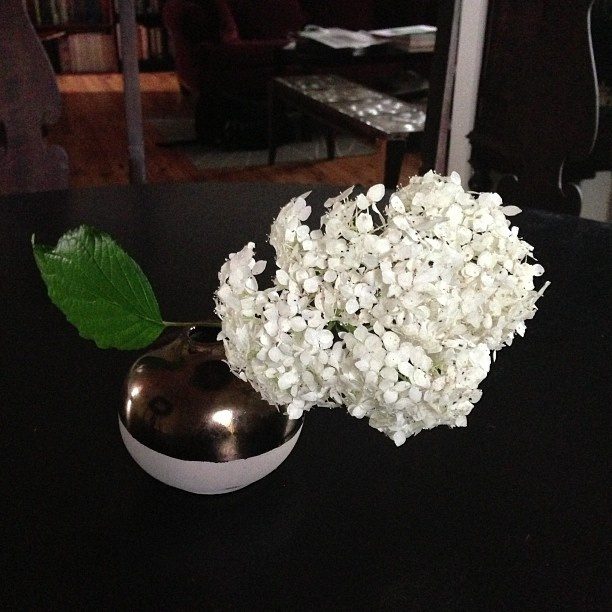Describe the objects in this image and their specific colors. I can see dining table in black, ivory, darkgray, and lightgray tones, vase in black and gray tones, couch in black, maroon, and gray tones, and couch in black and brown tones in this image. 